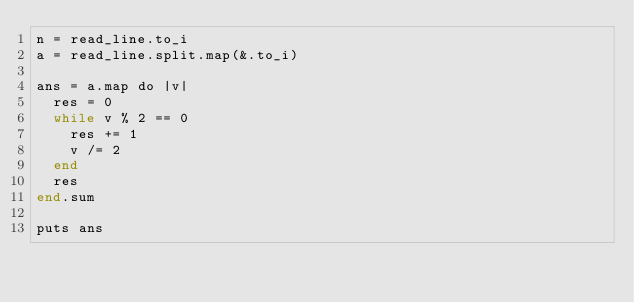<code> <loc_0><loc_0><loc_500><loc_500><_Crystal_>n = read_line.to_i
a = read_line.split.map(&.to_i)

ans = a.map do |v|
  res = 0
  while v % 2 == 0
    res += 1
    v /= 2
  end
  res
end.sum

puts ans
</code> 